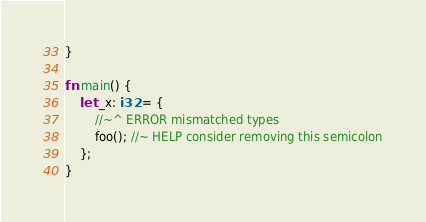<code> <loc_0><loc_0><loc_500><loc_500><_Rust_>}

fn main() {
    let _x: i32 = {
        //~^ ERROR mismatched types
        foo(); //~ HELP consider removing this semicolon
    };
}
</code> 